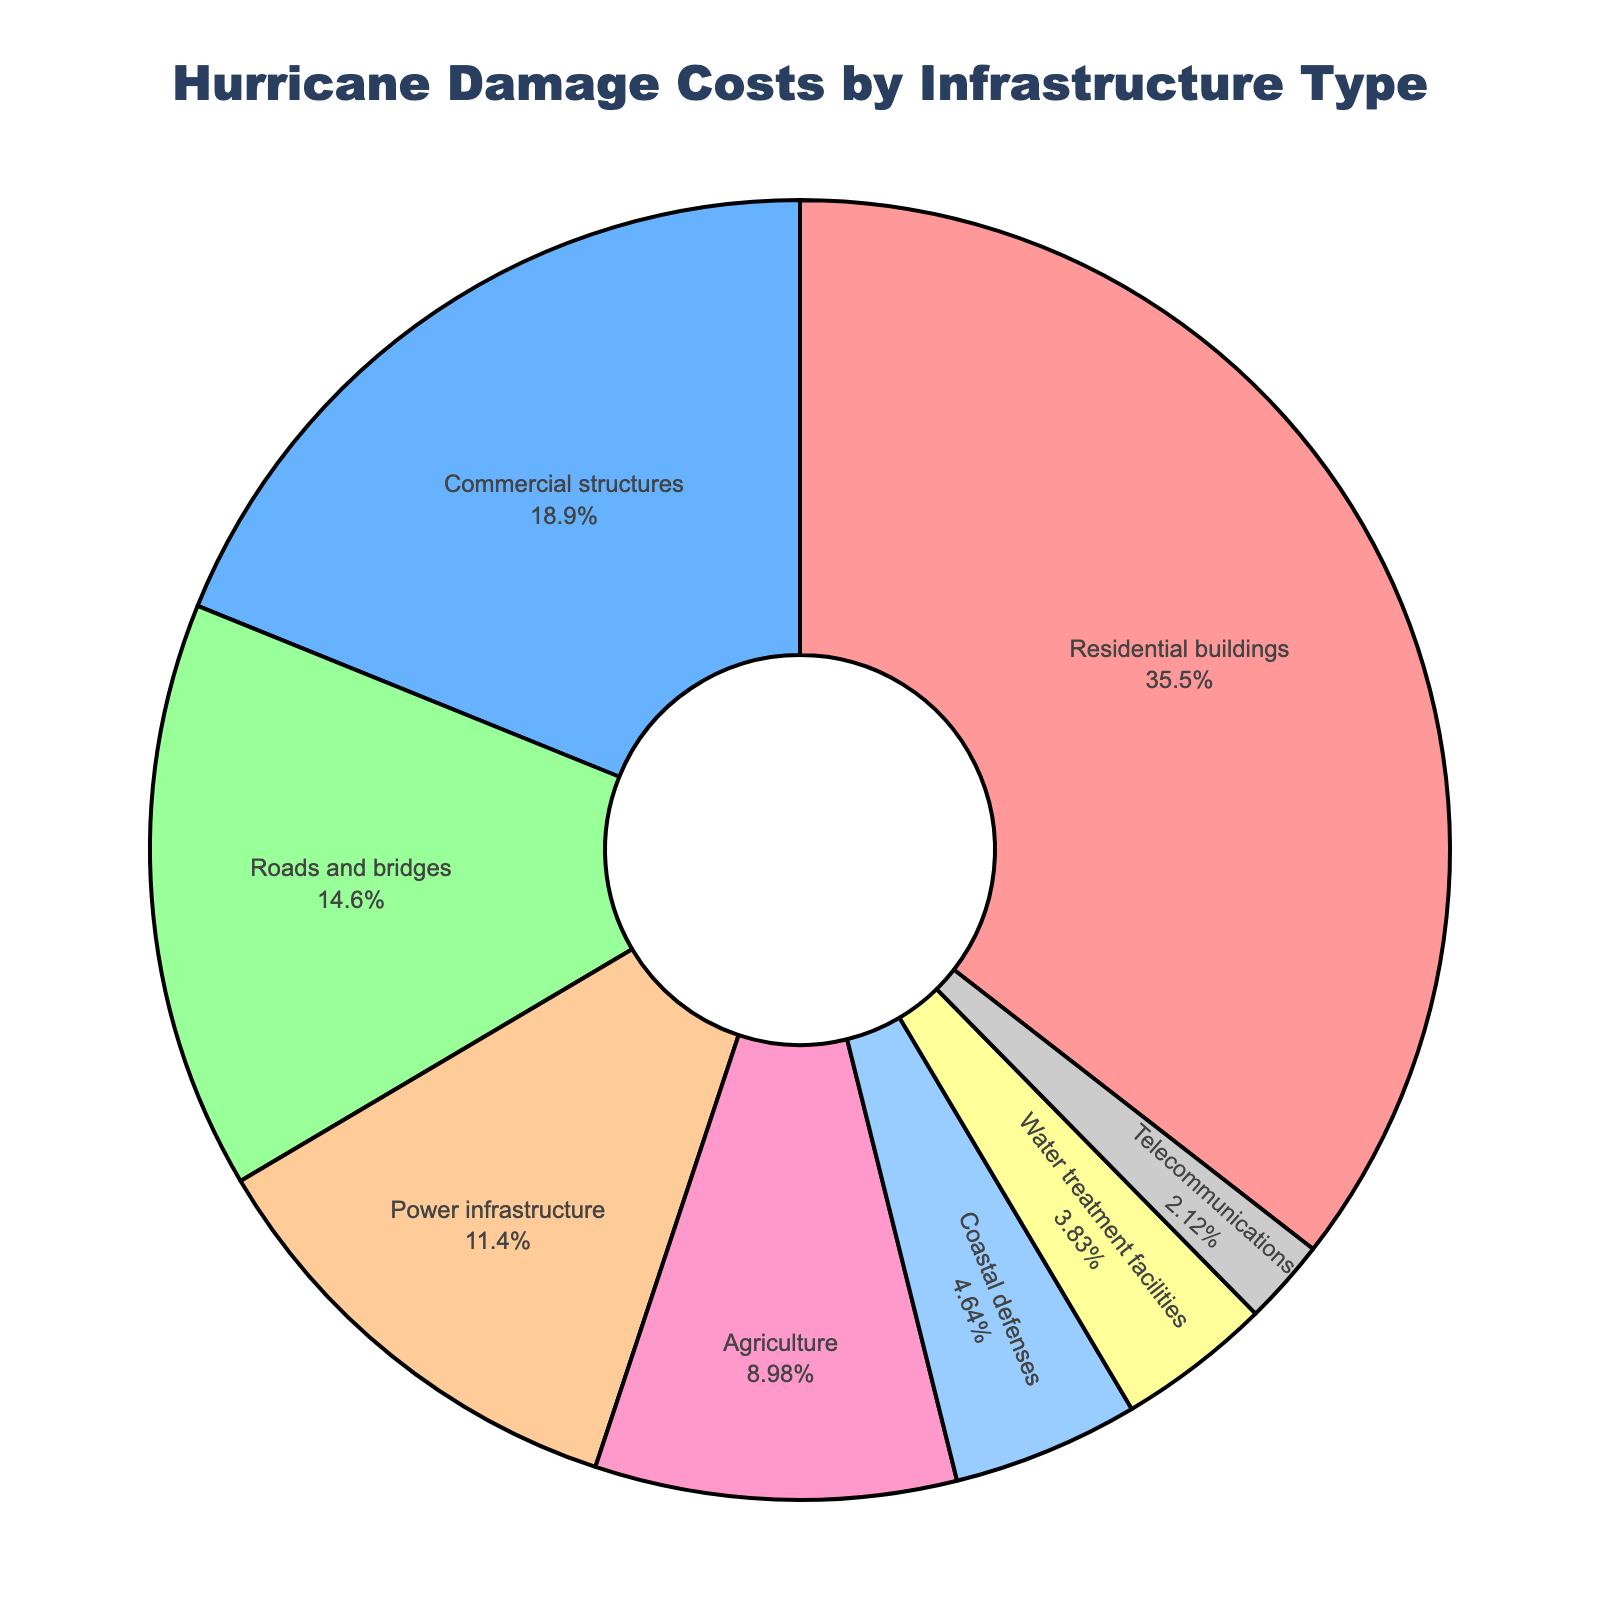what percentage of the total damage costs is attributed to residential buildings? The pie chart shows that residential buildings account for 35.2% of the total damage costs. This value is directly labeled in the figure.
Answer: 35.2% which category has the smallest portion of damage costs? By visually examining the pie chart, the segment labeled "Telecommunications" appears to be the smallest, which corresponds to 2.1% of the total damage costs.
Answer: Telecommunications how much greater is the percentage of damage costs for agricultural structures compared to water treatment facilities? From the figure, the percentage for agriculture is 8.9%, and for water treatment facilities, it is 3.8%. The difference is calculated as 8.9% - 3.8% = 5.1%.
Answer: 5.1% which category has a larger percentage: power infrastructure or commercial structures? The chart shows that commercial structures account for 18.7% while power infrastructure accounts for 11.3%. Therefore, commercial structures have a larger percentage.
Answer: Commercial structures how do the combined percentages of roads and bridges, and coastal defenses compare to the percentage for residential buildings? The combined percentage of roads and bridges (14.5%) and coastal defenses (4.6%) is 14.5% + 4.6% = 19.1%. This is less than the percentage for residential buildings, which is 35.2%.
Answer: Less what is the difference in percentage between the highest and lowest categories in the chart? The highest category is residential buildings at 35.2%, and the lowest is telecommunications at 2.1%. The difference is calculated as 35.2% - 2.1% = 33.1%.
Answer: 33.1% if the percentage for water treatment facilities doubled, would it surpass the percentage for agriculture? Doubling the percentage for water treatment facilities would be 2 * 3.8% = 7.6%, which is still less than agriculture's 8.9%.
Answer: No ranking from highest to lowest, which categories fall between commercial structures and coastal defenses? In descending order, the segments between commercial structures (18.7%) and coastal defenses (4.6%) include roads and bridges (14.5%), power infrastructure (11.3%), and agriculture (8.9%).
Answer: Roads and bridges, power infrastructure, agriculture what is the combined percentage of coastal defenses and telecommunications? The figure indicates that coastal defenses are 4.6% and telecommunications are 2.1%. Adding these together gives 4.6% + 2.1% = 6.7%.
Answer: 6.7% 